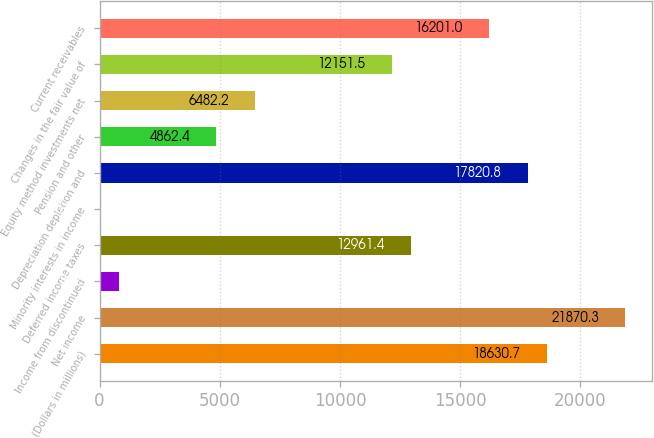Convert chart to OTSL. <chart><loc_0><loc_0><loc_500><loc_500><bar_chart><fcel>(Dollars in millions)<fcel>Net income<fcel>Income from discontinued<fcel>Deferred income taxes<fcel>Minority interests in income<fcel>Depreciation depletion and<fcel>Pension and other<fcel>Equity method investments net<fcel>Changes in the fair value of<fcel>Current receivables<nl><fcel>18630.7<fcel>21870.3<fcel>812.9<fcel>12961.4<fcel>3<fcel>17820.8<fcel>4862.4<fcel>6482.2<fcel>12151.5<fcel>16201<nl></chart> 